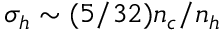<formula> <loc_0><loc_0><loc_500><loc_500>\sigma _ { h } \sim ( 5 / 3 2 ) n _ { c } / n _ { h }</formula> 